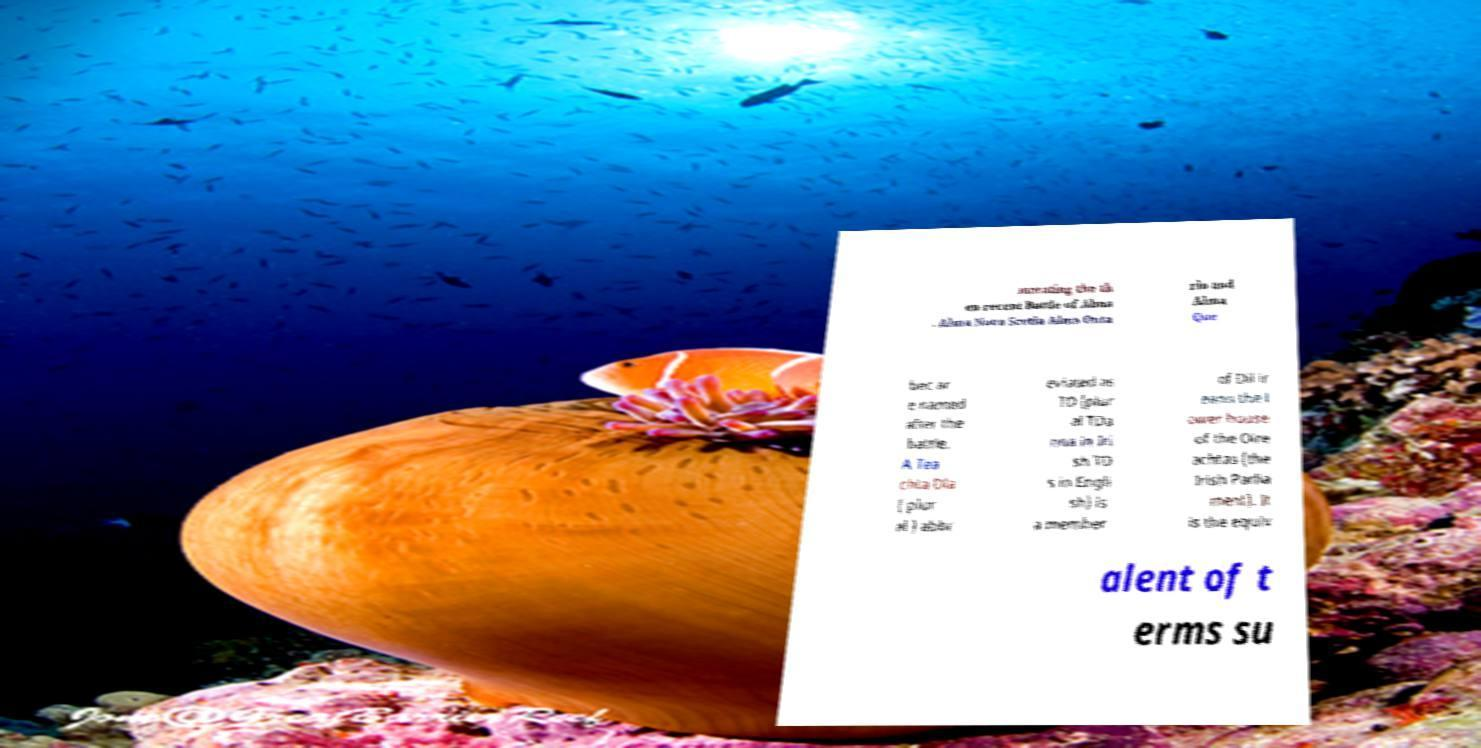What messages or text are displayed in this image? I need them in a readable, typed format. morating the th en-recent Battle of Alma . Alma Nova Scotia Alma Onta rio and Alma Que bec ar e named after the battle. A Tea chta Dla ( plur al ) abbr eviated as TD (plur al TDa nna in Iri sh TD s in Engli sh) is a member of Dil ir eann the l ower house of the Oire achtas (the Irish Parlia ment). It is the equiv alent of t erms su 